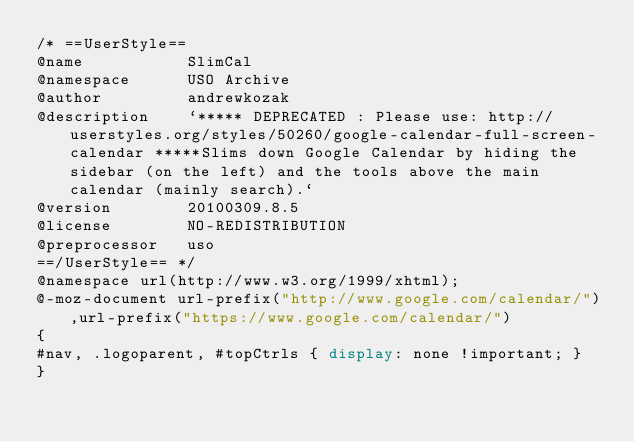Convert code to text. <code><loc_0><loc_0><loc_500><loc_500><_CSS_>/* ==UserStyle==
@name           SlimCal
@namespace      USO Archive
@author         andrewkozak
@description    `***** DEPRECATED : Please use: http://userstyles.org/styles/50260/google-calendar-full-screen-calendar *****Slims down Google Calendar by hiding the sidebar (on the left) and the tools above the main calendar (mainly search).`
@version        20100309.8.5
@license        NO-REDISTRIBUTION
@preprocessor   uso
==/UserStyle== */
@namespace url(http://www.w3.org/1999/xhtml);
@-moz-document url-prefix("http://www.google.com/calendar/"),url-prefix("https://www.google.com/calendar/")
{
#nav, .logoparent, #topCtrls { display: none !important; }
}</code> 